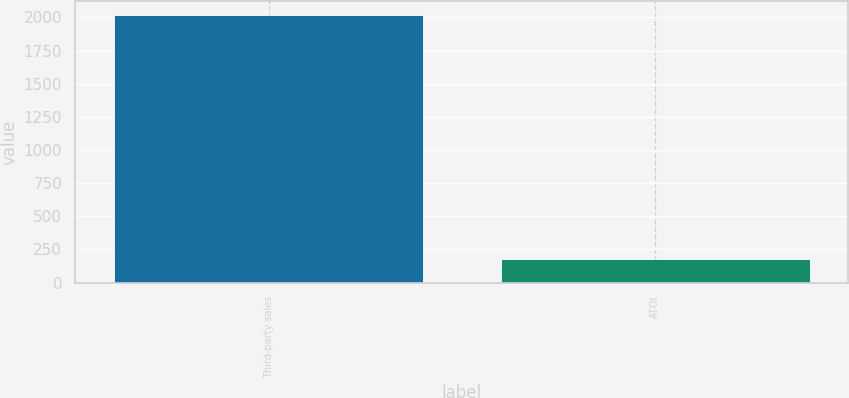Convert chart to OTSL. <chart><loc_0><loc_0><loc_500><loc_500><bar_chart><fcel>Third-party sales<fcel>ATOI<nl><fcel>2021<fcel>180<nl></chart> 